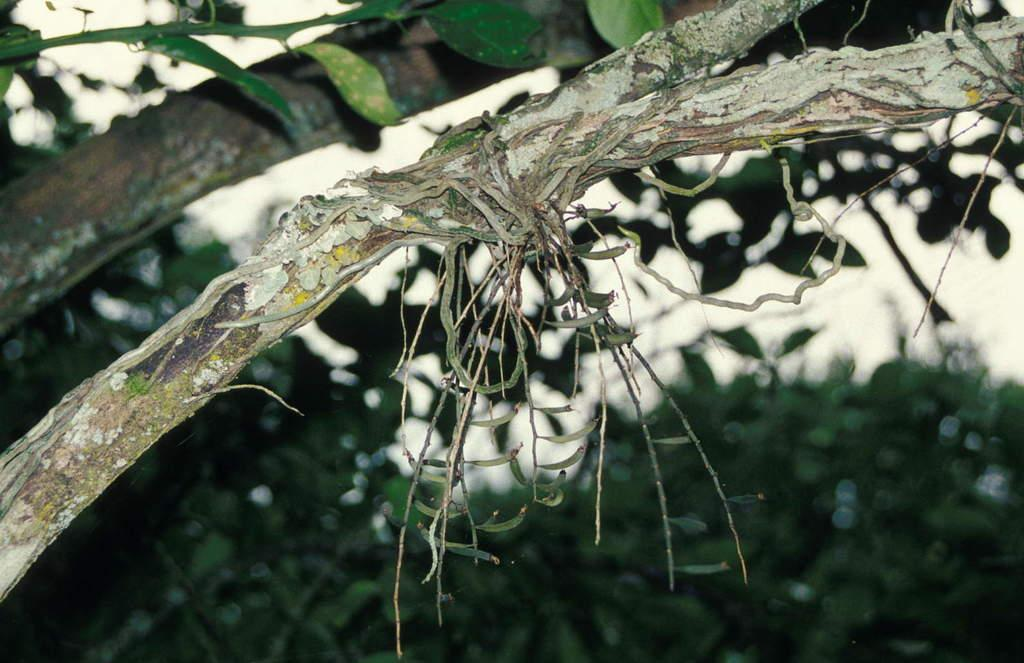What is the main subject of the image? The main subject of the image is a tree. What features of the tree can be observed? The tree has branches and leaves. How would you describe the background of the image? The background of the image is blurry. What type of mitten is hanging from the tree in the image? There is no mitten present in the image; it features a tree with branches and leaves. Is the tree made of steel in the image? No, the tree is not made of steel; it is a natural tree with branches and leaves. 